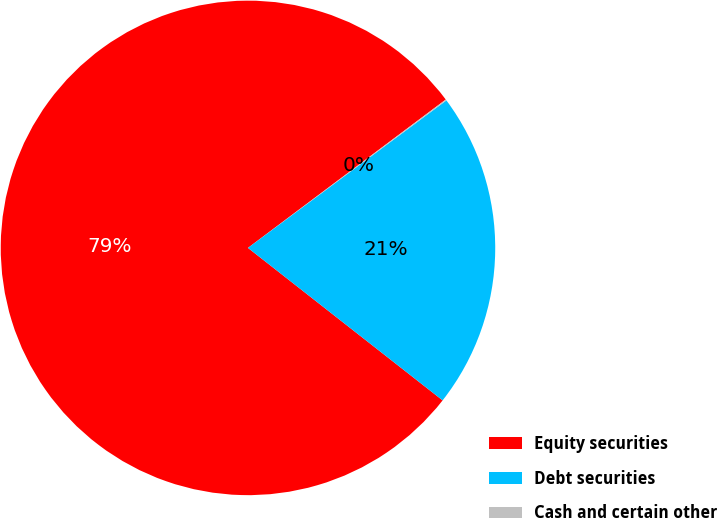<chart> <loc_0><loc_0><loc_500><loc_500><pie_chart><fcel>Equity securities<fcel>Debt securities<fcel>Cash and certain other<nl><fcel>79.18%<fcel>20.75%<fcel>0.07%<nl></chart> 